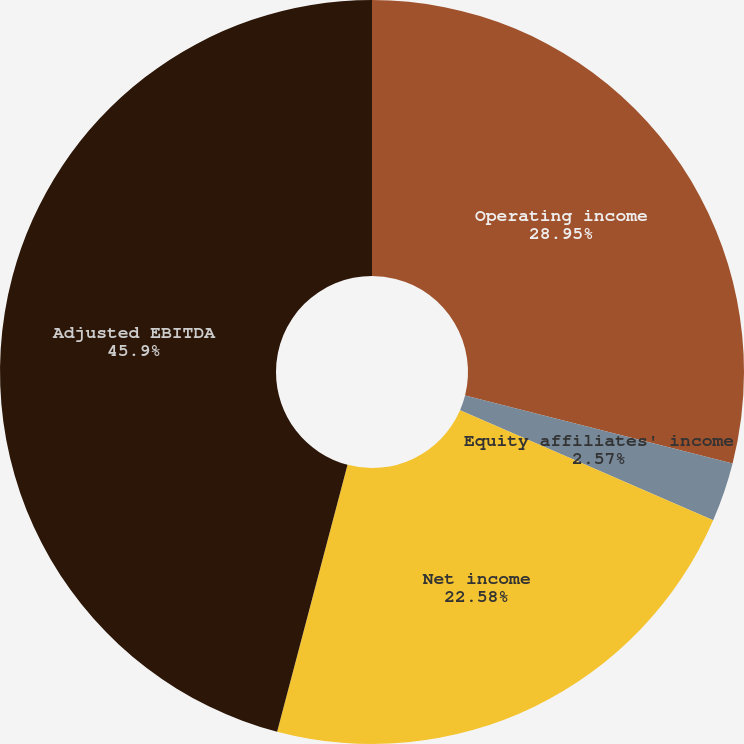Convert chart. <chart><loc_0><loc_0><loc_500><loc_500><pie_chart><fcel>Operating income<fcel>Equity affiliates' income<fcel>Net income<fcel>Adjusted EBITDA<nl><fcel>28.95%<fcel>2.57%<fcel>22.58%<fcel>45.89%<nl></chart> 